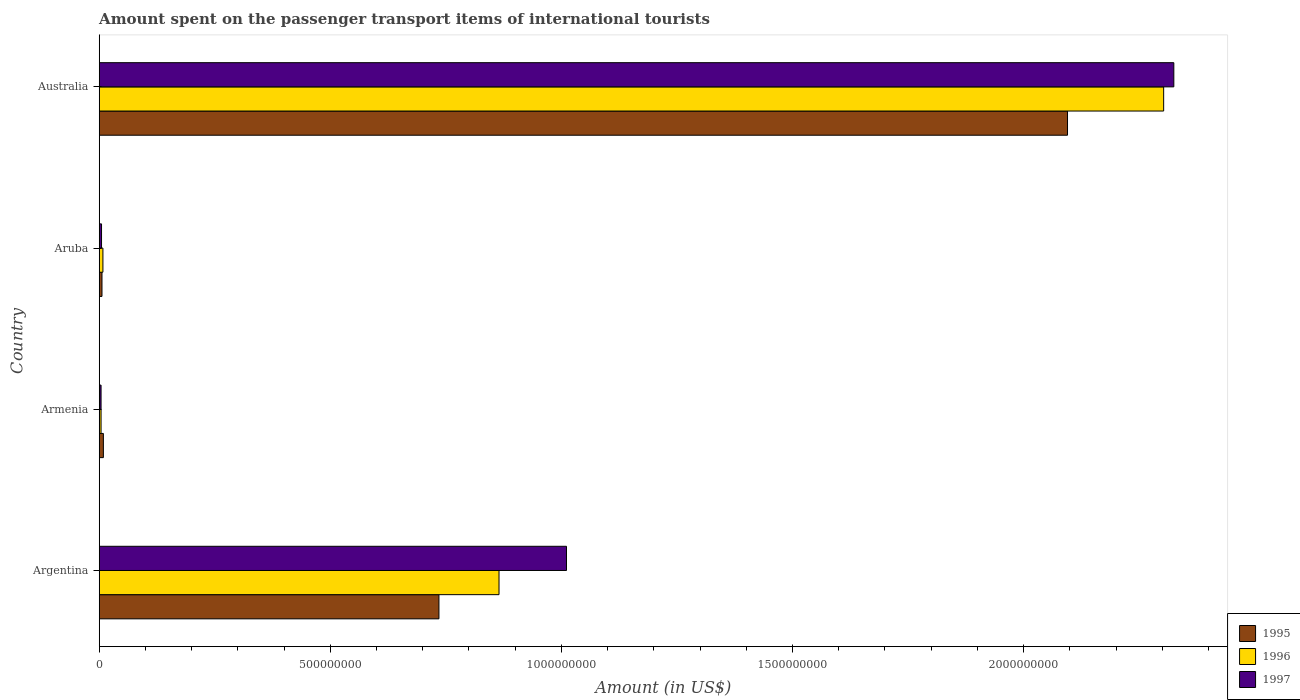How many groups of bars are there?
Offer a terse response. 4. Are the number of bars on each tick of the Y-axis equal?
Keep it short and to the point. Yes. How many bars are there on the 4th tick from the top?
Your answer should be very brief. 3. How many bars are there on the 1st tick from the bottom?
Provide a succinct answer. 3. Across all countries, what is the maximum amount spent on the passenger transport items of international tourists in 1997?
Give a very brief answer. 2.32e+09. Across all countries, what is the minimum amount spent on the passenger transport items of international tourists in 1995?
Keep it short and to the point. 6.00e+06. In which country was the amount spent on the passenger transport items of international tourists in 1995 minimum?
Ensure brevity in your answer.  Aruba. What is the total amount spent on the passenger transport items of international tourists in 1997 in the graph?
Your answer should be compact. 3.34e+09. What is the difference between the amount spent on the passenger transport items of international tourists in 1995 in Aruba and that in Australia?
Ensure brevity in your answer.  -2.09e+09. What is the difference between the amount spent on the passenger transport items of international tourists in 1996 in Argentina and the amount spent on the passenger transport items of international tourists in 1995 in Armenia?
Your response must be concise. 8.56e+08. What is the average amount spent on the passenger transport items of international tourists in 1997 per country?
Make the answer very short. 8.36e+08. What is the difference between the amount spent on the passenger transport items of international tourists in 1997 and amount spent on the passenger transport items of international tourists in 1995 in Australia?
Your response must be concise. 2.30e+08. In how many countries, is the amount spent on the passenger transport items of international tourists in 1995 greater than 400000000 US$?
Give a very brief answer. 2. What is the ratio of the amount spent on the passenger transport items of international tourists in 1995 in Armenia to that in Australia?
Offer a very short reply. 0. Is the amount spent on the passenger transport items of international tourists in 1997 in Armenia less than that in Aruba?
Your response must be concise. Yes. Is the difference between the amount spent on the passenger transport items of international tourists in 1997 in Argentina and Aruba greater than the difference between the amount spent on the passenger transport items of international tourists in 1995 in Argentina and Aruba?
Your response must be concise. Yes. What is the difference between the highest and the second highest amount spent on the passenger transport items of international tourists in 1995?
Make the answer very short. 1.36e+09. What is the difference between the highest and the lowest amount spent on the passenger transport items of international tourists in 1997?
Provide a succinct answer. 2.32e+09. What does the 1st bar from the top in Argentina represents?
Your response must be concise. 1997. Is it the case that in every country, the sum of the amount spent on the passenger transport items of international tourists in 1997 and amount spent on the passenger transport items of international tourists in 1995 is greater than the amount spent on the passenger transport items of international tourists in 1996?
Provide a succinct answer. Yes. How many bars are there?
Offer a terse response. 12. Are the values on the major ticks of X-axis written in scientific E-notation?
Keep it short and to the point. No. Does the graph contain any zero values?
Make the answer very short. No. Where does the legend appear in the graph?
Ensure brevity in your answer.  Bottom right. How many legend labels are there?
Provide a short and direct response. 3. What is the title of the graph?
Provide a succinct answer. Amount spent on the passenger transport items of international tourists. Does "1966" appear as one of the legend labels in the graph?
Your answer should be compact. No. What is the label or title of the X-axis?
Provide a succinct answer. Amount (in US$). What is the Amount (in US$) in 1995 in Argentina?
Give a very brief answer. 7.35e+08. What is the Amount (in US$) of 1996 in Argentina?
Keep it short and to the point. 8.65e+08. What is the Amount (in US$) in 1997 in Argentina?
Your answer should be very brief. 1.01e+09. What is the Amount (in US$) of 1995 in Armenia?
Give a very brief answer. 9.00e+06. What is the Amount (in US$) of 1996 in Armenia?
Make the answer very short. 4.00e+06. What is the Amount (in US$) in 1995 in Aruba?
Make the answer very short. 6.00e+06. What is the Amount (in US$) in 1996 in Aruba?
Keep it short and to the point. 8.00e+06. What is the Amount (in US$) in 1997 in Aruba?
Make the answer very short. 5.00e+06. What is the Amount (in US$) of 1995 in Australia?
Provide a succinct answer. 2.10e+09. What is the Amount (in US$) in 1996 in Australia?
Make the answer very short. 2.30e+09. What is the Amount (in US$) in 1997 in Australia?
Your answer should be very brief. 2.32e+09. Across all countries, what is the maximum Amount (in US$) in 1995?
Ensure brevity in your answer.  2.10e+09. Across all countries, what is the maximum Amount (in US$) in 1996?
Ensure brevity in your answer.  2.30e+09. Across all countries, what is the maximum Amount (in US$) of 1997?
Your answer should be compact. 2.32e+09. Across all countries, what is the minimum Amount (in US$) in 1995?
Provide a short and direct response. 6.00e+06. Across all countries, what is the minimum Amount (in US$) in 1996?
Keep it short and to the point. 4.00e+06. Across all countries, what is the minimum Amount (in US$) in 1997?
Your response must be concise. 4.00e+06. What is the total Amount (in US$) of 1995 in the graph?
Make the answer very short. 2.84e+09. What is the total Amount (in US$) in 1996 in the graph?
Give a very brief answer. 3.18e+09. What is the total Amount (in US$) of 1997 in the graph?
Your answer should be compact. 3.34e+09. What is the difference between the Amount (in US$) of 1995 in Argentina and that in Armenia?
Make the answer very short. 7.26e+08. What is the difference between the Amount (in US$) of 1996 in Argentina and that in Armenia?
Keep it short and to the point. 8.61e+08. What is the difference between the Amount (in US$) of 1997 in Argentina and that in Armenia?
Provide a succinct answer. 1.01e+09. What is the difference between the Amount (in US$) in 1995 in Argentina and that in Aruba?
Your answer should be compact. 7.29e+08. What is the difference between the Amount (in US$) in 1996 in Argentina and that in Aruba?
Provide a succinct answer. 8.57e+08. What is the difference between the Amount (in US$) of 1997 in Argentina and that in Aruba?
Provide a succinct answer. 1.01e+09. What is the difference between the Amount (in US$) of 1995 in Argentina and that in Australia?
Your answer should be very brief. -1.36e+09. What is the difference between the Amount (in US$) of 1996 in Argentina and that in Australia?
Provide a succinct answer. -1.44e+09. What is the difference between the Amount (in US$) of 1997 in Argentina and that in Australia?
Keep it short and to the point. -1.31e+09. What is the difference between the Amount (in US$) of 1995 in Armenia and that in Aruba?
Provide a short and direct response. 3.00e+06. What is the difference between the Amount (in US$) of 1996 in Armenia and that in Aruba?
Offer a very short reply. -4.00e+06. What is the difference between the Amount (in US$) in 1995 in Armenia and that in Australia?
Offer a terse response. -2.09e+09. What is the difference between the Amount (in US$) in 1996 in Armenia and that in Australia?
Provide a short and direct response. -2.30e+09. What is the difference between the Amount (in US$) in 1997 in Armenia and that in Australia?
Give a very brief answer. -2.32e+09. What is the difference between the Amount (in US$) in 1995 in Aruba and that in Australia?
Offer a terse response. -2.09e+09. What is the difference between the Amount (in US$) in 1996 in Aruba and that in Australia?
Make the answer very short. -2.30e+09. What is the difference between the Amount (in US$) in 1997 in Aruba and that in Australia?
Your answer should be compact. -2.32e+09. What is the difference between the Amount (in US$) of 1995 in Argentina and the Amount (in US$) of 1996 in Armenia?
Keep it short and to the point. 7.31e+08. What is the difference between the Amount (in US$) of 1995 in Argentina and the Amount (in US$) of 1997 in Armenia?
Offer a very short reply. 7.31e+08. What is the difference between the Amount (in US$) of 1996 in Argentina and the Amount (in US$) of 1997 in Armenia?
Offer a very short reply. 8.61e+08. What is the difference between the Amount (in US$) of 1995 in Argentina and the Amount (in US$) of 1996 in Aruba?
Your answer should be compact. 7.27e+08. What is the difference between the Amount (in US$) of 1995 in Argentina and the Amount (in US$) of 1997 in Aruba?
Your answer should be very brief. 7.30e+08. What is the difference between the Amount (in US$) of 1996 in Argentina and the Amount (in US$) of 1997 in Aruba?
Your answer should be compact. 8.60e+08. What is the difference between the Amount (in US$) in 1995 in Argentina and the Amount (in US$) in 1996 in Australia?
Offer a very short reply. -1.57e+09. What is the difference between the Amount (in US$) in 1995 in Argentina and the Amount (in US$) in 1997 in Australia?
Make the answer very short. -1.59e+09. What is the difference between the Amount (in US$) of 1996 in Argentina and the Amount (in US$) of 1997 in Australia?
Your answer should be compact. -1.46e+09. What is the difference between the Amount (in US$) in 1995 in Armenia and the Amount (in US$) in 1996 in Aruba?
Make the answer very short. 1.00e+06. What is the difference between the Amount (in US$) of 1995 in Armenia and the Amount (in US$) of 1997 in Aruba?
Ensure brevity in your answer.  4.00e+06. What is the difference between the Amount (in US$) in 1996 in Armenia and the Amount (in US$) in 1997 in Aruba?
Make the answer very short. -1.00e+06. What is the difference between the Amount (in US$) in 1995 in Armenia and the Amount (in US$) in 1996 in Australia?
Provide a succinct answer. -2.29e+09. What is the difference between the Amount (in US$) of 1995 in Armenia and the Amount (in US$) of 1997 in Australia?
Give a very brief answer. -2.32e+09. What is the difference between the Amount (in US$) in 1996 in Armenia and the Amount (in US$) in 1997 in Australia?
Your answer should be compact. -2.32e+09. What is the difference between the Amount (in US$) of 1995 in Aruba and the Amount (in US$) of 1996 in Australia?
Your response must be concise. -2.30e+09. What is the difference between the Amount (in US$) in 1995 in Aruba and the Amount (in US$) in 1997 in Australia?
Ensure brevity in your answer.  -2.32e+09. What is the difference between the Amount (in US$) of 1996 in Aruba and the Amount (in US$) of 1997 in Australia?
Offer a very short reply. -2.32e+09. What is the average Amount (in US$) of 1995 per country?
Make the answer very short. 7.11e+08. What is the average Amount (in US$) in 1996 per country?
Offer a very short reply. 7.95e+08. What is the average Amount (in US$) in 1997 per country?
Your response must be concise. 8.36e+08. What is the difference between the Amount (in US$) of 1995 and Amount (in US$) of 1996 in Argentina?
Keep it short and to the point. -1.30e+08. What is the difference between the Amount (in US$) in 1995 and Amount (in US$) in 1997 in Argentina?
Provide a short and direct response. -2.76e+08. What is the difference between the Amount (in US$) in 1996 and Amount (in US$) in 1997 in Argentina?
Make the answer very short. -1.46e+08. What is the difference between the Amount (in US$) of 1995 and Amount (in US$) of 1997 in Armenia?
Provide a succinct answer. 5.00e+06. What is the difference between the Amount (in US$) of 1996 and Amount (in US$) of 1997 in Armenia?
Your answer should be compact. 0. What is the difference between the Amount (in US$) in 1995 and Amount (in US$) in 1996 in Australia?
Your response must be concise. -2.08e+08. What is the difference between the Amount (in US$) of 1995 and Amount (in US$) of 1997 in Australia?
Keep it short and to the point. -2.30e+08. What is the difference between the Amount (in US$) of 1996 and Amount (in US$) of 1997 in Australia?
Provide a short and direct response. -2.20e+07. What is the ratio of the Amount (in US$) in 1995 in Argentina to that in Armenia?
Make the answer very short. 81.67. What is the ratio of the Amount (in US$) of 1996 in Argentina to that in Armenia?
Give a very brief answer. 216.25. What is the ratio of the Amount (in US$) in 1997 in Argentina to that in Armenia?
Your answer should be very brief. 252.75. What is the ratio of the Amount (in US$) of 1995 in Argentina to that in Aruba?
Keep it short and to the point. 122.5. What is the ratio of the Amount (in US$) of 1996 in Argentina to that in Aruba?
Ensure brevity in your answer.  108.12. What is the ratio of the Amount (in US$) in 1997 in Argentina to that in Aruba?
Provide a succinct answer. 202.2. What is the ratio of the Amount (in US$) in 1995 in Argentina to that in Australia?
Ensure brevity in your answer.  0.35. What is the ratio of the Amount (in US$) in 1996 in Argentina to that in Australia?
Your answer should be compact. 0.38. What is the ratio of the Amount (in US$) of 1997 in Argentina to that in Australia?
Make the answer very short. 0.43. What is the ratio of the Amount (in US$) in 1995 in Armenia to that in Aruba?
Your answer should be compact. 1.5. What is the ratio of the Amount (in US$) in 1996 in Armenia to that in Aruba?
Keep it short and to the point. 0.5. What is the ratio of the Amount (in US$) in 1997 in Armenia to that in Aruba?
Provide a succinct answer. 0.8. What is the ratio of the Amount (in US$) of 1995 in Armenia to that in Australia?
Ensure brevity in your answer.  0. What is the ratio of the Amount (in US$) in 1996 in Armenia to that in Australia?
Keep it short and to the point. 0. What is the ratio of the Amount (in US$) in 1997 in Armenia to that in Australia?
Ensure brevity in your answer.  0. What is the ratio of the Amount (in US$) of 1995 in Aruba to that in Australia?
Provide a short and direct response. 0. What is the ratio of the Amount (in US$) in 1996 in Aruba to that in Australia?
Keep it short and to the point. 0. What is the ratio of the Amount (in US$) in 1997 in Aruba to that in Australia?
Make the answer very short. 0. What is the difference between the highest and the second highest Amount (in US$) in 1995?
Ensure brevity in your answer.  1.36e+09. What is the difference between the highest and the second highest Amount (in US$) of 1996?
Your response must be concise. 1.44e+09. What is the difference between the highest and the second highest Amount (in US$) of 1997?
Offer a very short reply. 1.31e+09. What is the difference between the highest and the lowest Amount (in US$) of 1995?
Make the answer very short. 2.09e+09. What is the difference between the highest and the lowest Amount (in US$) of 1996?
Offer a very short reply. 2.30e+09. What is the difference between the highest and the lowest Amount (in US$) in 1997?
Keep it short and to the point. 2.32e+09. 